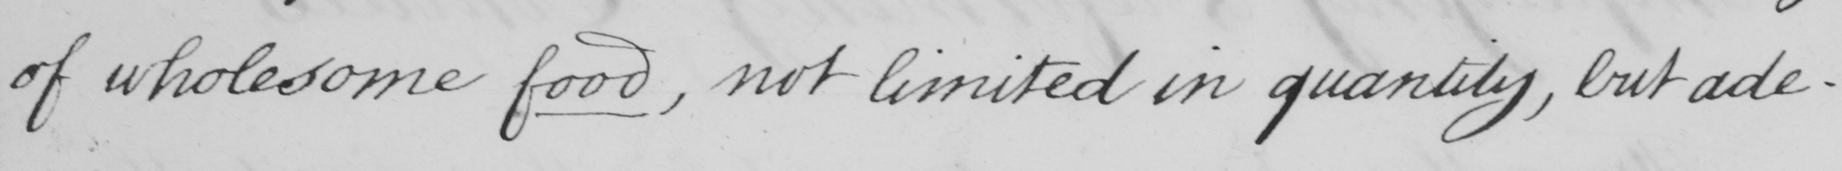Can you tell me what this handwritten text says? of wholesome food, not limited in quantity, but ade- 